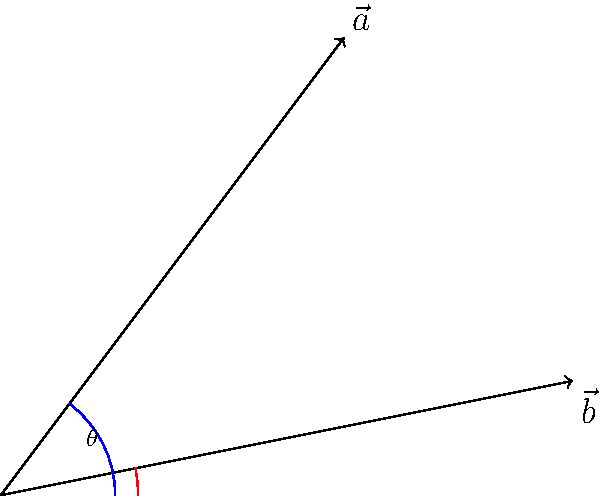During a crucial match at Angisa Arena, two corner kicks were taken from different corners. The trajectories of these kicks can be represented by vectors $\vec{a} = (3,4)$ and $\vec{b} = (5,1)$. What is the angle (in degrees, rounded to the nearest whole number) between these two vectors? To find the angle between two vectors, we can use the dot product formula:

$$\cos \theta = \frac{\vec{a} \cdot \vec{b}}{|\vec{a}||\vec{b}|}$$

Step 1: Calculate the dot product $\vec{a} \cdot \vec{b}$
$$\vec{a} \cdot \vec{b} = (3 \times 5) + (4 \times 1) = 15 + 4 = 19$$

Step 2: Calculate the magnitudes of the vectors
$$|\vec{a}| = \sqrt{3^2 + 4^2} = \sqrt{9 + 16} = \sqrt{25} = 5$$
$$|\vec{b}| = \sqrt{5^2 + 1^2} = \sqrt{25 + 1} = \sqrt{26}$$

Step 3: Apply the formula
$$\cos \theta = \frac{19}{5\sqrt{26}}$$

Step 4: Take the inverse cosine (arccos) of both sides
$$\theta = \arccos(\frac{19}{5\sqrt{26}})$$

Step 5: Convert to degrees and round to the nearest whole number
$$\theta \approx 22.33^\circ \approx 22^\circ$$
Answer: 22° 